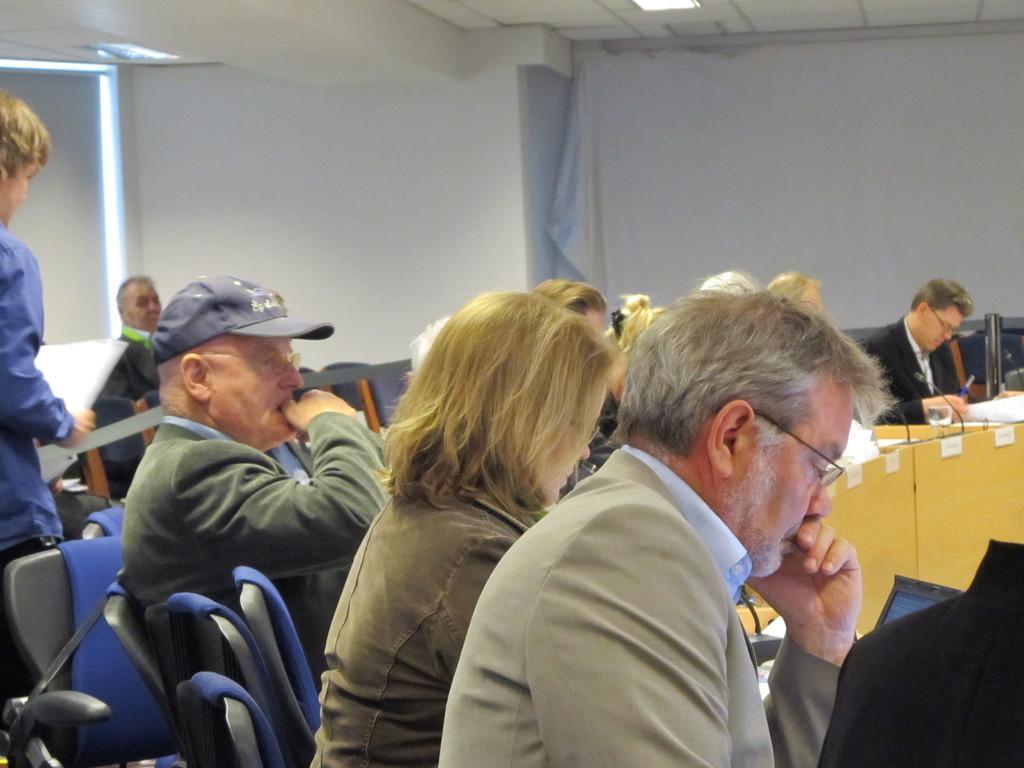Describe this image in one or two sentences. In this image we can see some people sitting on the chairs. On the right side we can see a person sitting near a table containing mike's, pen, flask and some papers. On the right side we can see a person standing holding some papers. On the backside we can see a roof with some ceiling lights. 